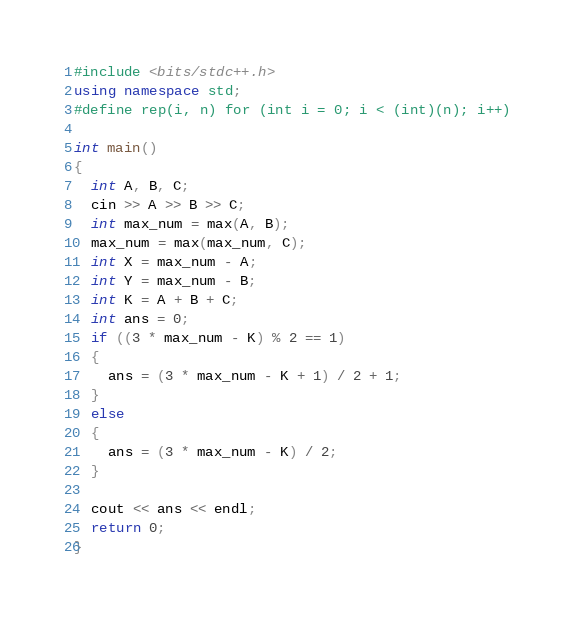<code> <loc_0><loc_0><loc_500><loc_500><_C++_>#include <bits/stdc++.h>
using namespace std;
#define rep(i, n) for (int i = 0; i < (int)(n); i++)

int main()
{
  int A, B, C;
  cin >> A >> B >> C;
  int max_num = max(A, B);
  max_num = max(max_num, C);
  int X = max_num - A;
  int Y = max_num - B;
  int K = A + B + C;
  int ans = 0;
  if ((3 * max_num - K) % 2 == 1)
  {
    ans = (3 * max_num - K + 1) / 2 + 1;
  }
  else
  {
    ans = (3 * max_num - K) / 2;
  }

  cout << ans << endl;
  return 0;
}</code> 